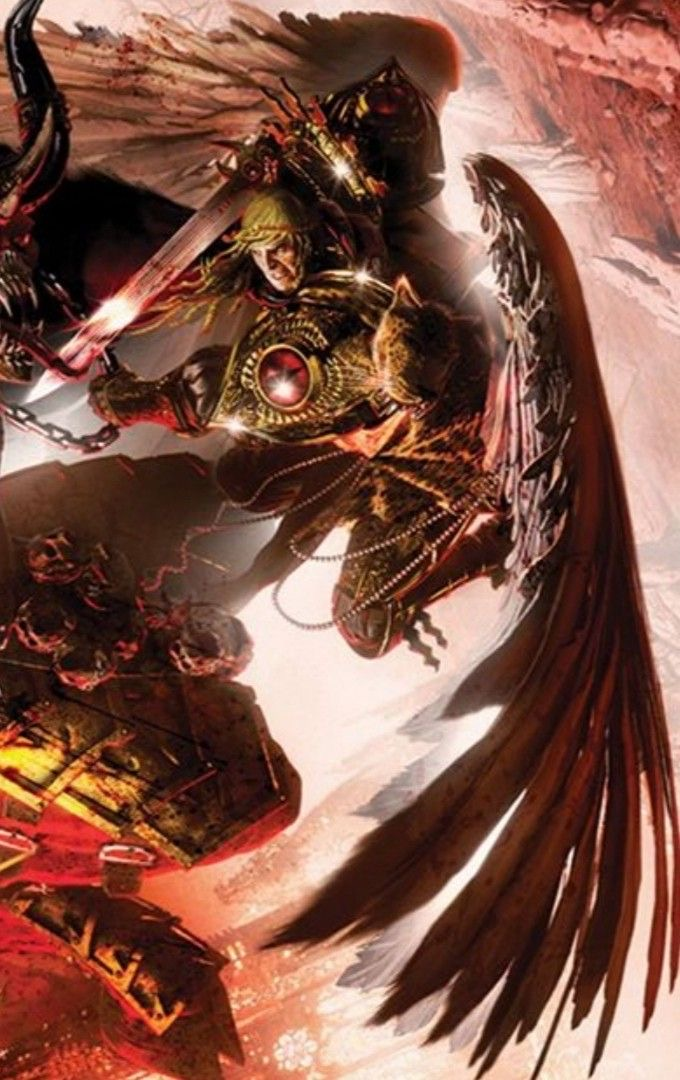describe This image features a dramatic and detailed illustration of a fantasy character, likely a warrior or knight. The character is adorned in ornate armor with golden and red accents, suggesting a regal or high-ranking status. The armor includes intricate designs, chains, and a prominent central gem, which could signify a source of power or importance.

The character has an intense expression and is wielding a weapon with a glowing, energy-like effect, emphasizing action or combat. Most striking are the large, expansive wings that emerge from the character's back, which are rendered with a mix of feather-like and mechanical elements, giving a blend of organic and armored appearance.

The background suggests a rocky, possibly volcanic environment, adding to the dramatic and perilous atmosphere of the scene. This setting and the character's attire and posture all contribute to a narrative of epic battles and mythical adventures. 